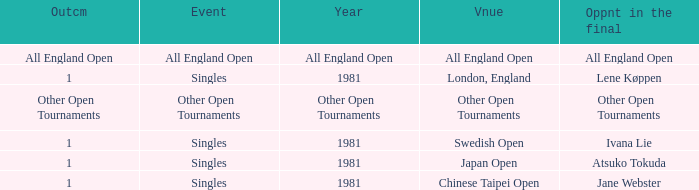Who was the Opponent in London, England with an Outcome of 1? Lene Køppen. Would you be able to parse every entry in this table? {'header': ['Outcm', 'Event', 'Year', 'Vnue', 'Oppnt in the final'], 'rows': [['All England Open', 'All England Open', 'All England Open', 'All England Open', 'All England Open'], ['1', 'Singles', '1981', 'London, England', 'Lene Køppen'], ['Other Open Tournaments', 'Other Open Tournaments', 'Other Open Tournaments', 'Other Open Tournaments', 'Other Open Tournaments'], ['1', 'Singles', '1981', 'Swedish Open', 'Ivana Lie'], ['1', 'Singles', '1981', 'Japan Open', 'Atsuko Tokuda'], ['1', 'Singles', '1981', 'Chinese Taipei Open', 'Jane Webster']]} 